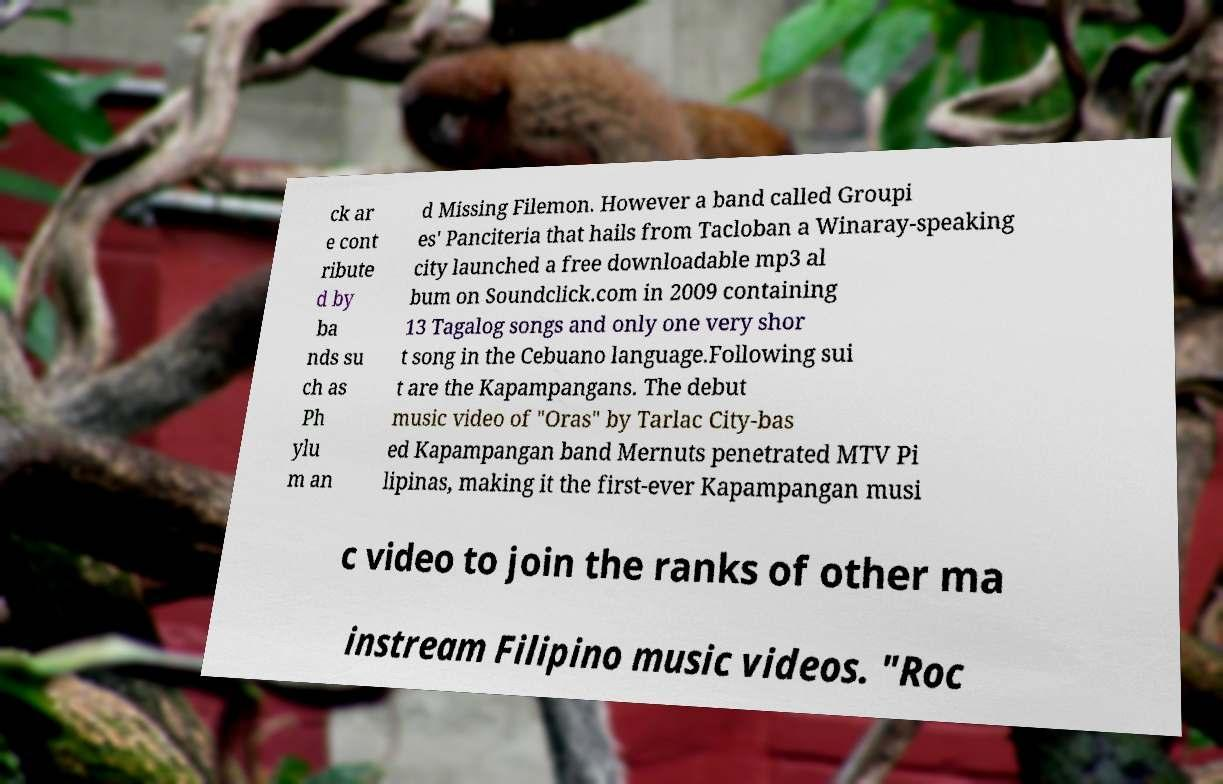There's text embedded in this image that I need extracted. Can you transcribe it verbatim? ck ar e cont ribute d by ba nds su ch as Ph ylu m an d Missing Filemon. However a band called Groupi es' Panciteria that hails from Tacloban a Winaray-speaking city launched a free downloadable mp3 al bum on Soundclick.com in 2009 containing 13 Tagalog songs and only one very shor t song in the Cebuano language.Following sui t are the Kapampangans. The debut music video of "Oras" by Tarlac City-bas ed Kapampangan band Mernuts penetrated MTV Pi lipinas, making it the first-ever Kapampangan musi c video to join the ranks of other ma instream Filipino music videos. "Roc 